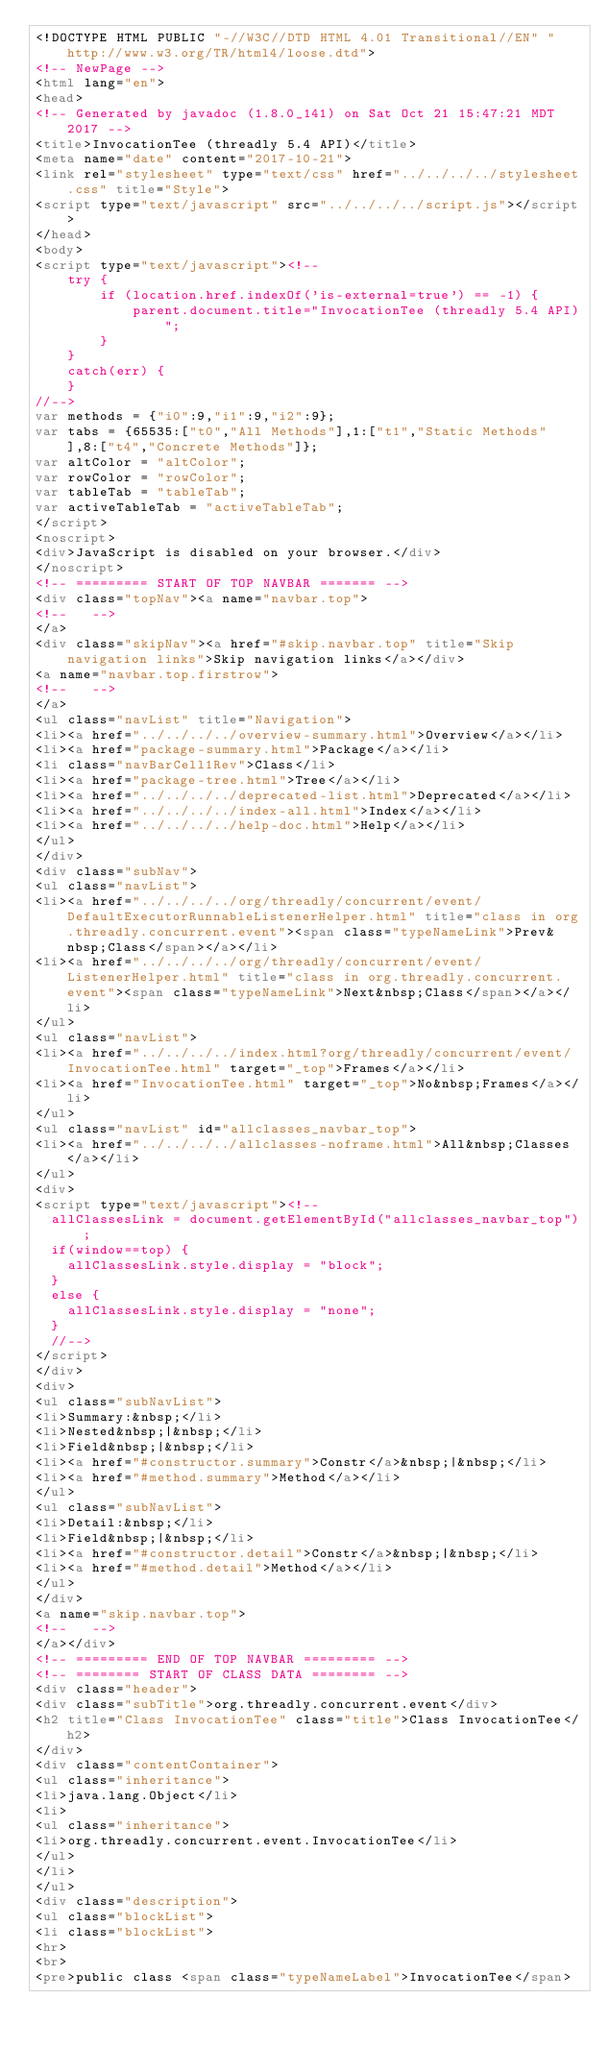<code> <loc_0><loc_0><loc_500><loc_500><_HTML_><!DOCTYPE HTML PUBLIC "-//W3C//DTD HTML 4.01 Transitional//EN" "http://www.w3.org/TR/html4/loose.dtd">
<!-- NewPage -->
<html lang="en">
<head>
<!-- Generated by javadoc (1.8.0_141) on Sat Oct 21 15:47:21 MDT 2017 -->
<title>InvocationTee (threadly 5.4 API)</title>
<meta name="date" content="2017-10-21">
<link rel="stylesheet" type="text/css" href="../../../../stylesheet.css" title="Style">
<script type="text/javascript" src="../../../../script.js"></script>
</head>
<body>
<script type="text/javascript"><!--
    try {
        if (location.href.indexOf('is-external=true') == -1) {
            parent.document.title="InvocationTee (threadly 5.4 API)";
        }
    }
    catch(err) {
    }
//-->
var methods = {"i0":9,"i1":9,"i2":9};
var tabs = {65535:["t0","All Methods"],1:["t1","Static Methods"],8:["t4","Concrete Methods"]};
var altColor = "altColor";
var rowColor = "rowColor";
var tableTab = "tableTab";
var activeTableTab = "activeTableTab";
</script>
<noscript>
<div>JavaScript is disabled on your browser.</div>
</noscript>
<!-- ========= START OF TOP NAVBAR ======= -->
<div class="topNav"><a name="navbar.top">
<!--   -->
</a>
<div class="skipNav"><a href="#skip.navbar.top" title="Skip navigation links">Skip navigation links</a></div>
<a name="navbar.top.firstrow">
<!--   -->
</a>
<ul class="navList" title="Navigation">
<li><a href="../../../../overview-summary.html">Overview</a></li>
<li><a href="package-summary.html">Package</a></li>
<li class="navBarCell1Rev">Class</li>
<li><a href="package-tree.html">Tree</a></li>
<li><a href="../../../../deprecated-list.html">Deprecated</a></li>
<li><a href="../../../../index-all.html">Index</a></li>
<li><a href="../../../../help-doc.html">Help</a></li>
</ul>
</div>
<div class="subNav">
<ul class="navList">
<li><a href="../../../../org/threadly/concurrent/event/DefaultExecutorRunnableListenerHelper.html" title="class in org.threadly.concurrent.event"><span class="typeNameLink">Prev&nbsp;Class</span></a></li>
<li><a href="../../../../org/threadly/concurrent/event/ListenerHelper.html" title="class in org.threadly.concurrent.event"><span class="typeNameLink">Next&nbsp;Class</span></a></li>
</ul>
<ul class="navList">
<li><a href="../../../../index.html?org/threadly/concurrent/event/InvocationTee.html" target="_top">Frames</a></li>
<li><a href="InvocationTee.html" target="_top">No&nbsp;Frames</a></li>
</ul>
<ul class="navList" id="allclasses_navbar_top">
<li><a href="../../../../allclasses-noframe.html">All&nbsp;Classes</a></li>
</ul>
<div>
<script type="text/javascript"><!--
  allClassesLink = document.getElementById("allclasses_navbar_top");
  if(window==top) {
    allClassesLink.style.display = "block";
  }
  else {
    allClassesLink.style.display = "none";
  }
  //-->
</script>
</div>
<div>
<ul class="subNavList">
<li>Summary:&nbsp;</li>
<li>Nested&nbsp;|&nbsp;</li>
<li>Field&nbsp;|&nbsp;</li>
<li><a href="#constructor.summary">Constr</a>&nbsp;|&nbsp;</li>
<li><a href="#method.summary">Method</a></li>
</ul>
<ul class="subNavList">
<li>Detail:&nbsp;</li>
<li>Field&nbsp;|&nbsp;</li>
<li><a href="#constructor.detail">Constr</a>&nbsp;|&nbsp;</li>
<li><a href="#method.detail">Method</a></li>
</ul>
</div>
<a name="skip.navbar.top">
<!--   -->
</a></div>
<!-- ========= END OF TOP NAVBAR ========= -->
<!-- ======== START OF CLASS DATA ======== -->
<div class="header">
<div class="subTitle">org.threadly.concurrent.event</div>
<h2 title="Class InvocationTee" class="title">Class InvocationTee</h2>
</div>
<div class="contentContainer">
<ul class="inheritance">
<li>java.lang.Object</li>
<li>
<ul class="inheritance">
<li>org.threadly.concurrent.event.InvocationTee</li>
</ul>
</li>
</ul>
<div class="description">
<ul class="blockList">
<li class="blockList">
<hr>
<br>
<pre>public class <span class="typeNameLabel">InvocationTee</span></code> 